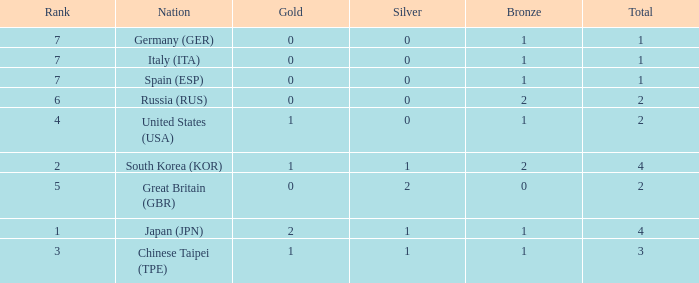I'm looking to parse the entire table for insights. Could you assist me with that? {'header': ['Rank', 'Nation', 'Gold', 'Silver', 'Bronze', 'Total'], 'rows': [['7', 'Germany (GER)', '0', '0', '1', '1'], ['7', 'Italy (ITA)', '0', '0', '1', '1'], ['7', 'Spain (ESP)', '0', '0', '1', '1'], ['6', 'Russia (RUS)', '0', '0', '2', '2'], ['4', 'United States (USA)', '1', '0', '1', '2'], ['2', 'South Korea (KOR)', '1', '1', '2', '4'], ['5', 'Great Britain (GBR)', '0', '2', '0', '2'], ['1', 'Japan (JPN)', '2', '1', '1', '4'], ['3', 'Chinese Taipei (TPE)', '1', '1', '1', '3']]} What is the smallest number of gold of a country of rank 6, with 2 bronzes? None. 